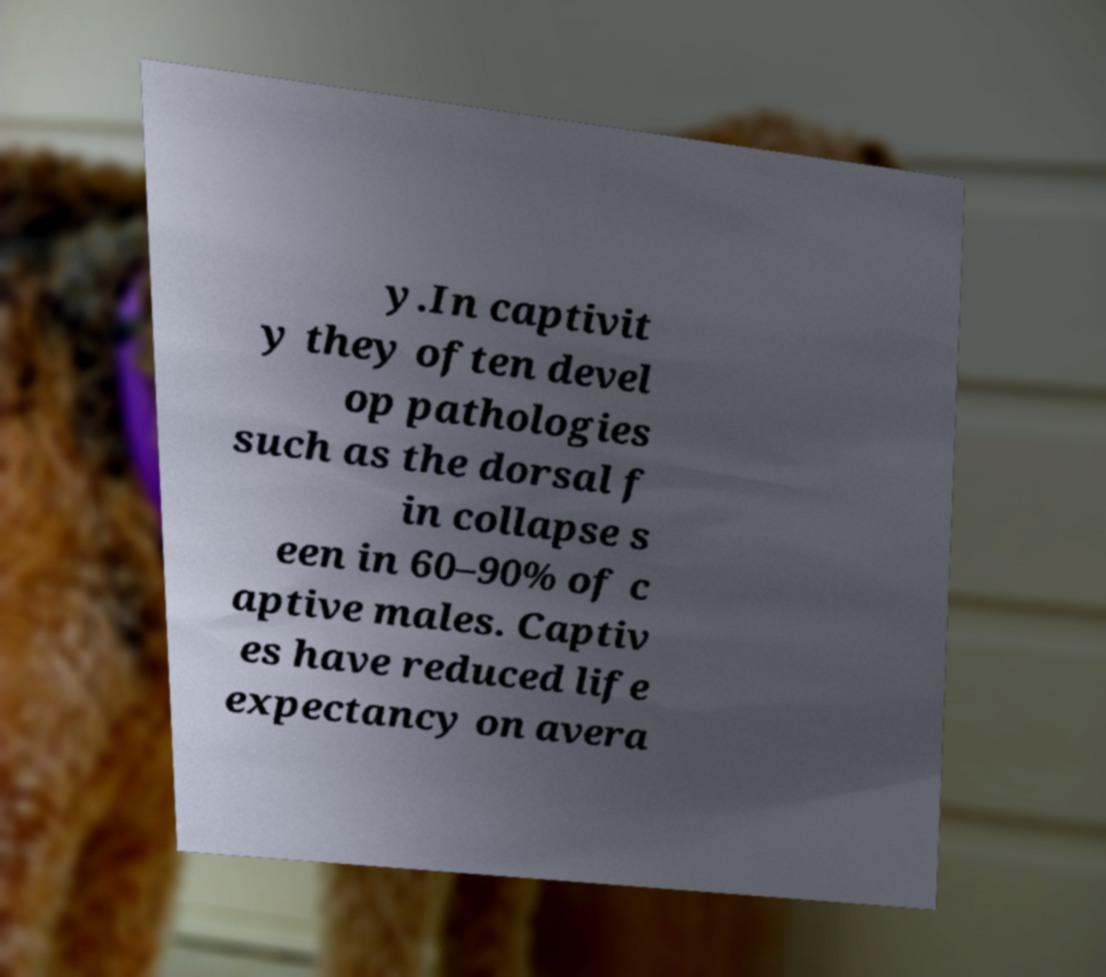Can you read and provide the text displayed in the image?This photo seems to have some interesting text. Can you extract and type it out for me? y.In captivit y they often devel op pathologies such as the dorsal f in collapse s een in 60–90% of c aptive males. Captiv es have reduced life expectancy on avera 